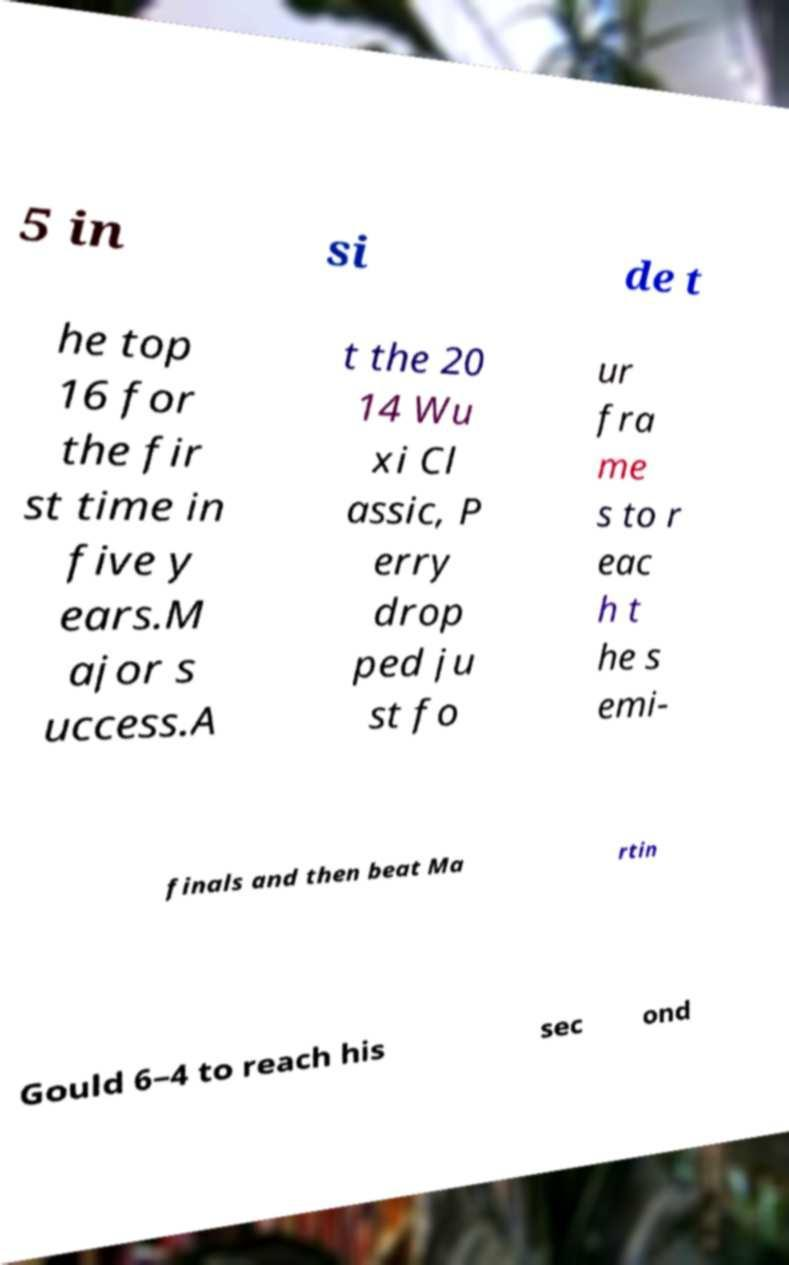For documentation purposes, I need the text within this image transcribed. Could you provide that? 5 in si de t he top 16 for the fir st time in five y ears.M ajor s uccess.A t the 20 14 Wu xi Cl assic, P erry drop ped ju st fo ur fra me s to r eac h t he s emi- finals and then beat Ma rtin Gould 6–4 to reach his sec ond 